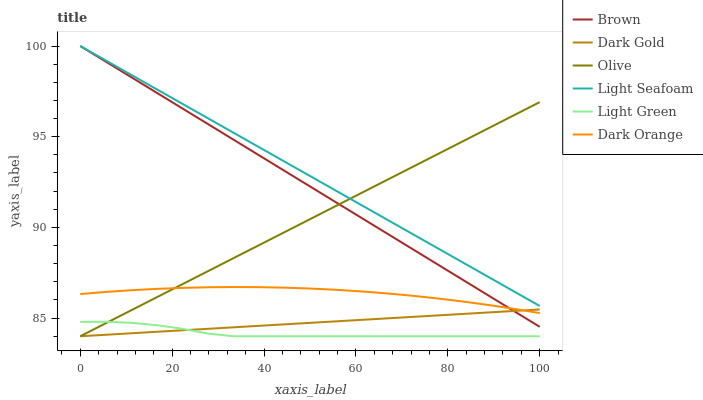Does Light Green have the minimum area under the curve?
Answer yes or no. Yes. Does Light Seafoam have the maximum area under the curve?
Answer yes or no. Yes. Does Dark Orange have the minimum area under the curve?
Answer yes or no. No. Does Dark Orange have the maximum area under the curve?
Answer yes or no. No. Is Light Seafoam the smoothest?
Answer yes or no. Yes. Is Light Green the roughest?
Answer yes or no. Yes. Is Dark Orange the smoothest?
Answer yes or no. No. Is Dark Orange the roughest?
Answer yes or no. No. Does Dark Gold have the lowest value?
Answer yes or no. Yes. Does Dark Orange have the lowest value?
Answer yes or no. No. Does Light Seafoam have the highest value?
Answer yes or no. Yes. Does Dark Orange have the highest value?
Answer yes or no. No. Is Light Green less than Brown?
Answer yes or no. Yes. Is Dark Orange greater than Light Green?
Answer yes or no. Yes. Does Olive intersect Dark Gold?
Answer yes or no. Yes. Is Olive less than Dark Gold?
Answer yes or no. No. Is Olive greater than Dark Gold?
Answer yes or no. No. Does Light Green intersect Brown?
Answer yes or no. No. 